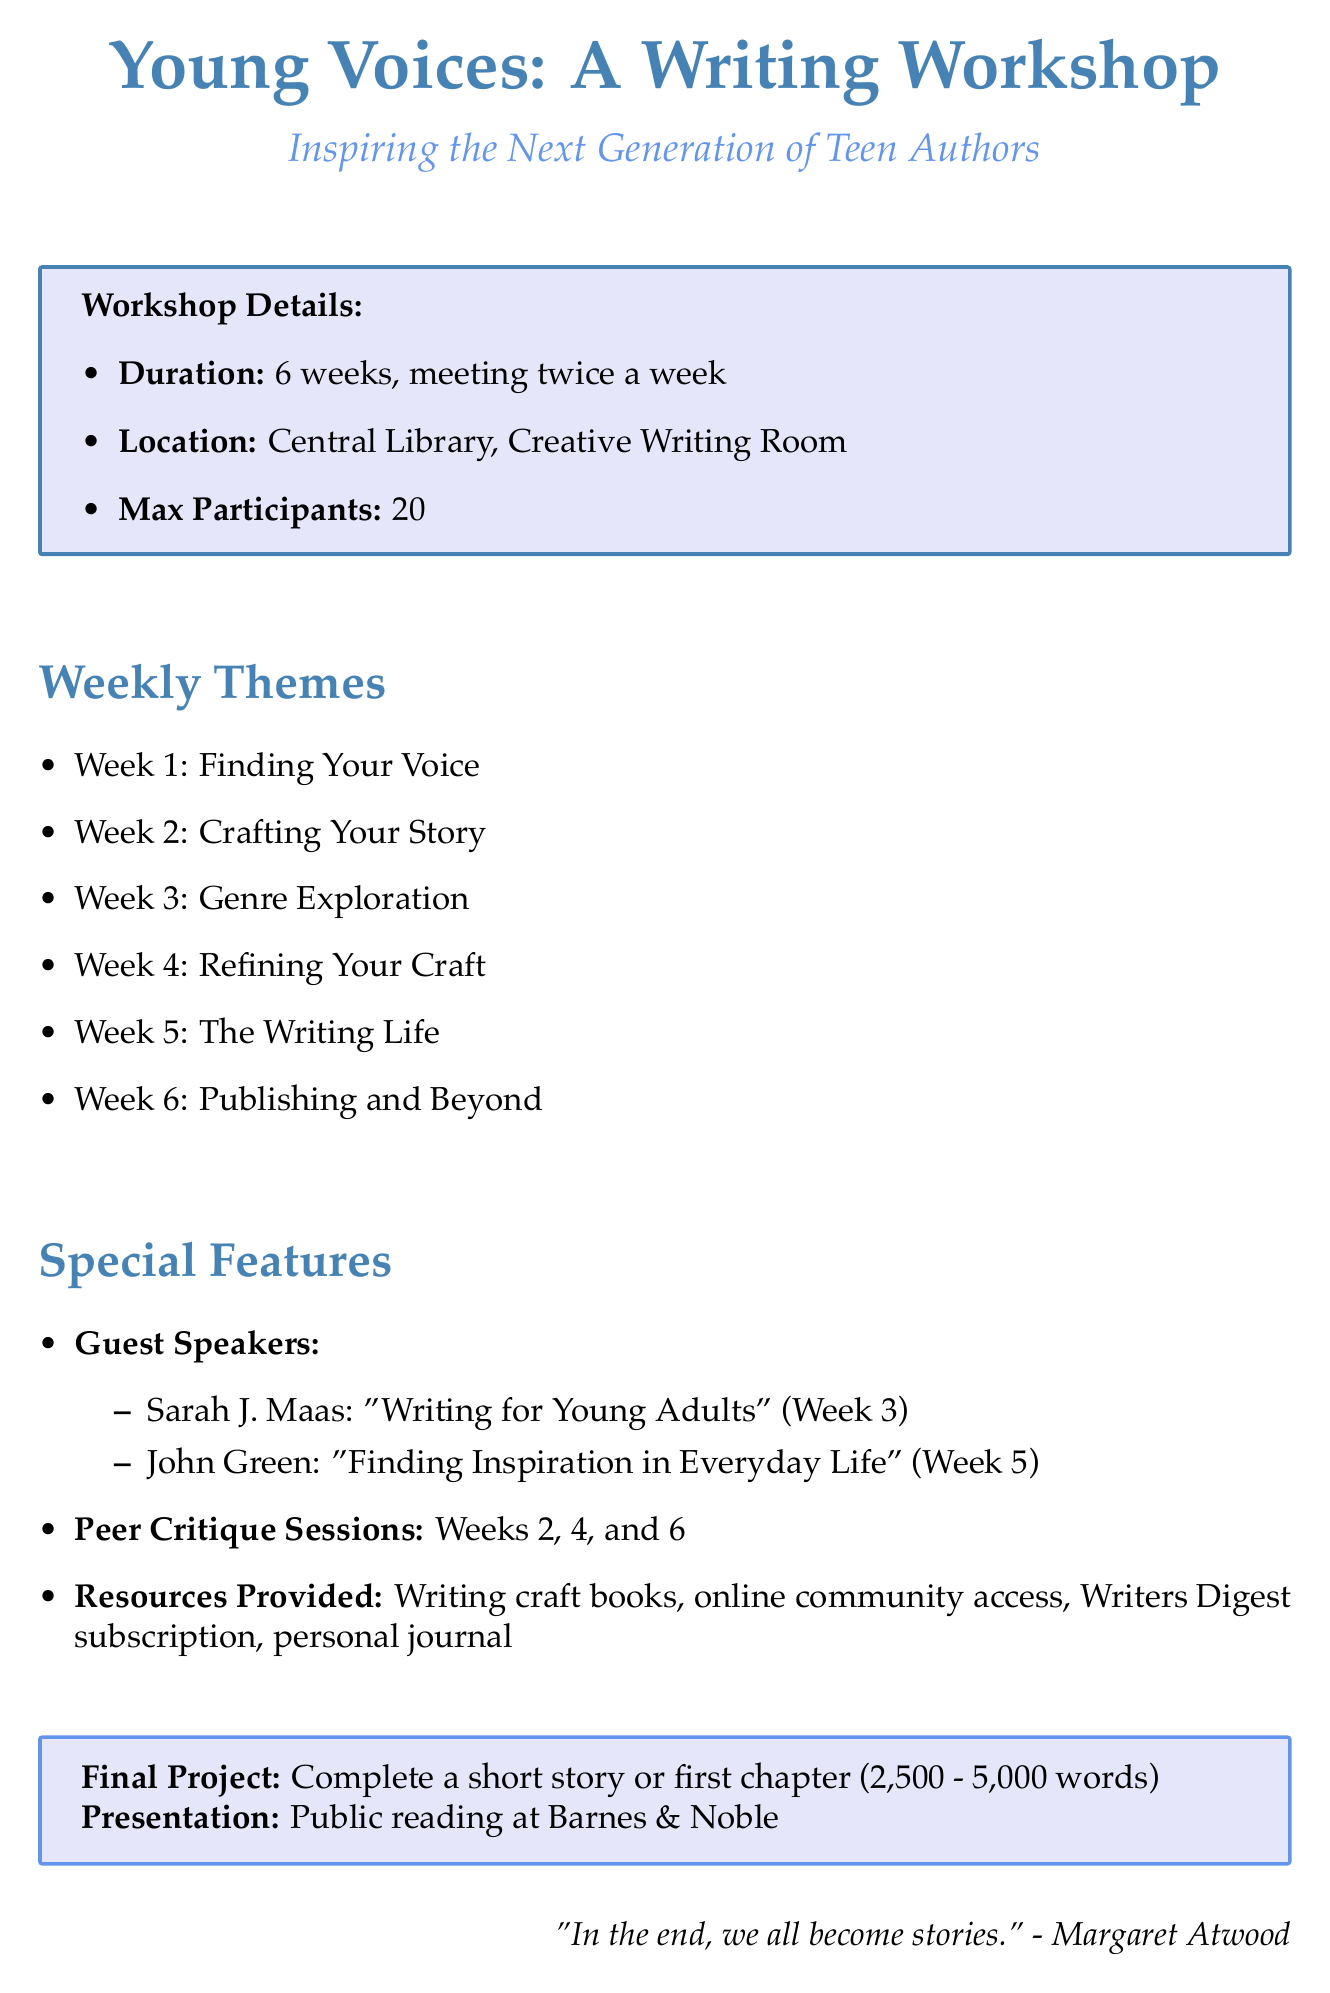What is the title of the workshop? The title of the workshop is stated clearly in the document as "Young Voices: A Writing Workshop for Aspiring Teen Authors."
Answer: Young Voices: A Writing Workshop for Aspiring Teen Authors How many weeks does the workshop last? The duration of the workshop is provided in the details, which states it lasts for 6 weeks.
Answer: 6 weeks What is the maximum number of participants allowed? The document specifies that the maximum number of participants is 20.
Answer: 20 Who is the guest speaker for Week 3? The memo lists the guest speakers, indicating that Sarah J. Maas will be the speaker for Week 3.
Answer: Sarah J. Maas What is the focus of the peer critique session in Week 4? The document indicates the focus of the peer critique session for Week 4 is "Plot and Pacing."
Answer: Plot and Pacing What type of project are participants required to submit at the end of the workshop? The final project description in the document states that participants must complete a short story or the first chapter of a novel.
Answer: Complete a short story or first chapter of a novel What resources are provided during the workshop? The document lists multiple resources provided, including writing craft books and access to online writing communities.
Answer: Writing craft books, online community access, Writers Digest subscription, personal journal What is the submission date for the final project? The final project submission date is specifically mentioned in the document, stating it is due in Week 6, Tuesday.
Answer: Week 6, Tuesday 